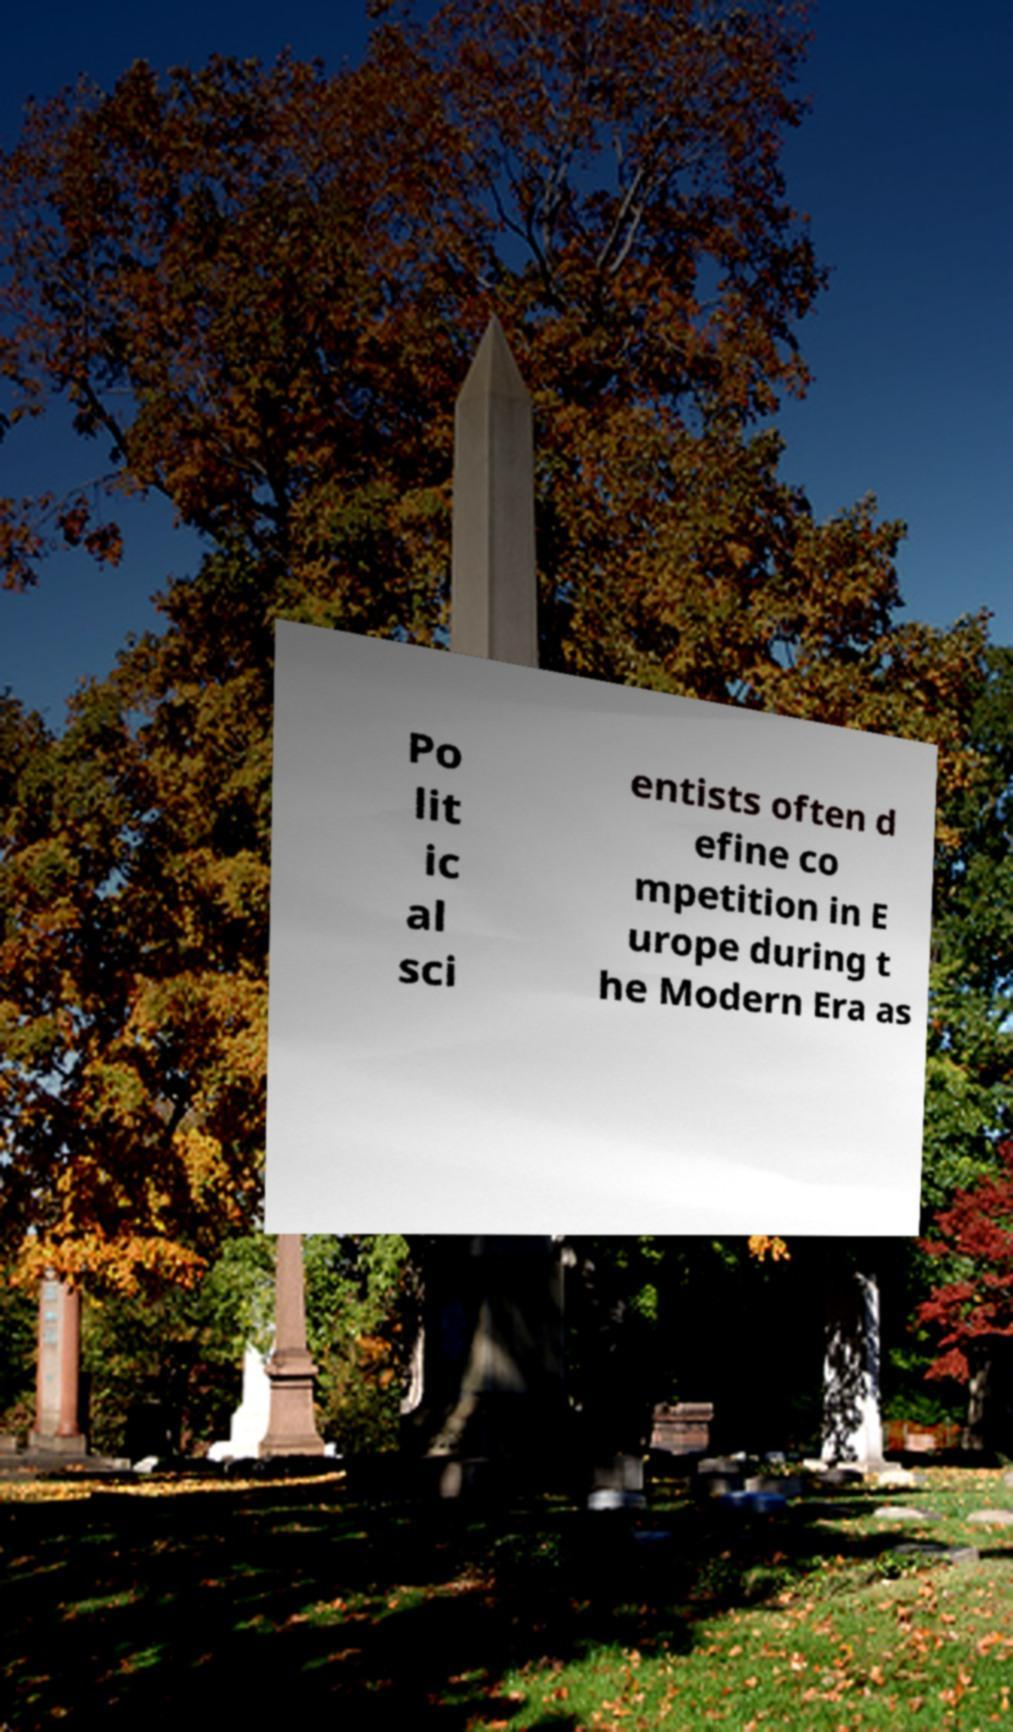What messages or text are displayed in this image? I need them in a readable, typed format. Po lit ic al sci entists often d efine co mpetition in E urope during t he Modern Era as 